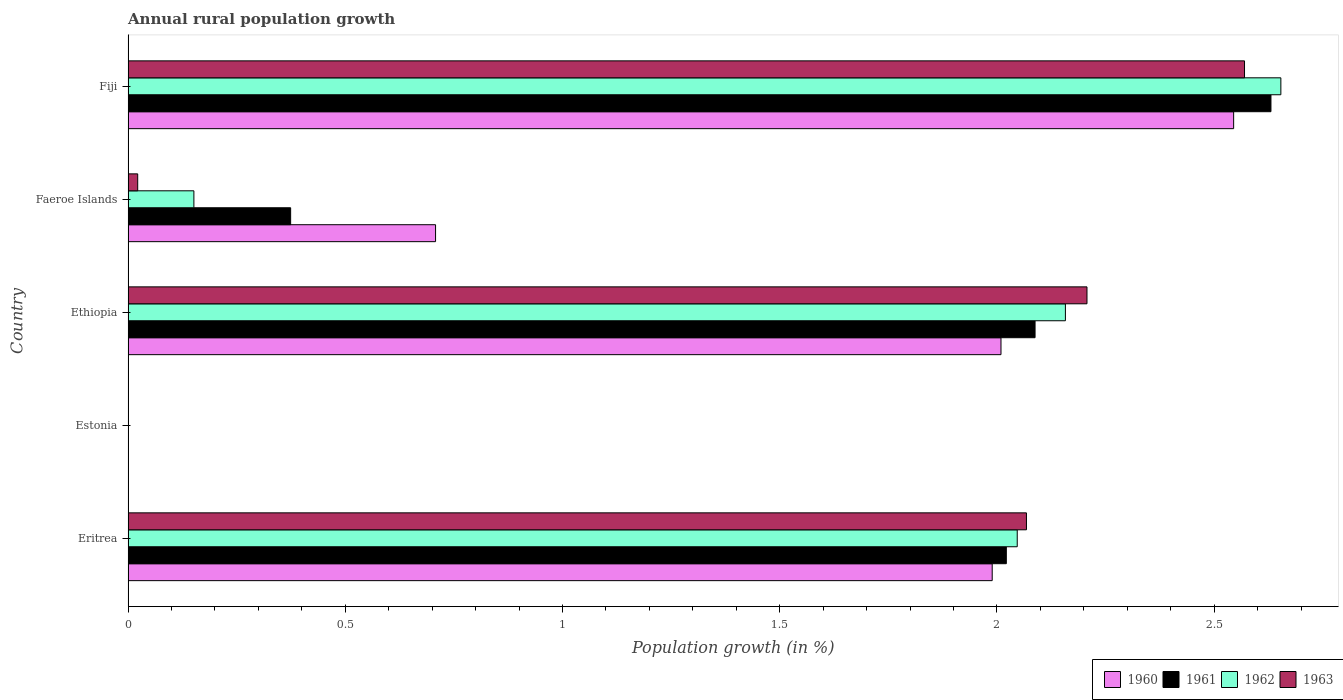How many different coloured bars are there?
Make the answer very short. 4. Are the number of bars per tick equal to the number of legend labels?
Your response must be concise. No. Are the number of bars on each tick of the Y-axis equal?
Offer a very short reply. No. How many bars are there on the 4th tick from the top?
Offer a terse response. 0. How many bars are there on the 2nd tick from the bottom?
Keep it short and to the point. 0. What is the label of the 4th group of bars from the top?
Offer a very short reply. Estonia. In how many cases, is the number of bars for a given country not equal to the number of legend labels?
Your answer should be very brief. 1. What is the percentage of rural population growth in 1960 in Faeroe Islands?
Ensure brevity in your answer.  0.71. Across all countries, what is the maximum percentage of rural population growth in 1963?
Provide a short and direct response. 2.57. In which country was the percentage of rural population growth in 1962 maximum?
Make the answer very short. Fiji. What is the total percentage of rural population growth in 1963 in the graph?
Offer a very short reply. 6.87. What is the difference between the percentage of rural population growth in 1962 in Eritrea and that in Fiji?
Offer a terse response. -0.61. What is the difference between the percentage of rural population growth in 1960 in Fiji and the percentage of rural population growth in 1962 in Estonia?
Offer a very short reply. 2.54. What is the average percentage of rural population growth in 1960 per country?
Keep it short and to the point. 1.45. What is the difference between the percentage of rural population growth in 1960 and percentage of rural population growth in 1962 in Ethiopia?
Provide a succinct answer. -0.15. In how many countries, is the percentage of rural population growth in 1960 greater than 0.9 %?
Give a very brief answer. 3. What is the ratio of the percentage of rural population growth in 1960 in Ethiopia to that in Fiji?
Offer a terse response. 0.79. What is the difference between the highest and the second highest percentage of rural population growth in 1961?
Provide a succinct answer. 0.54. What is the difference between the highest and the lowest percentage of rural population growth in 1962?
Your answer should be compact. 2.65. In how many countries, is the percentage of rural population growth in 1962 greater than the average percentage of rural population growth in 1962 taken over all countries?
Your answer should be very brief. 3. Is the sum of the percentage of rural population growth in 1962 in Faeroe Islands and Fiji greater than the maximum percentage of rural population growth in 1960 across all countries?
Keep it short and to the point. Yes. How many countries are there in the graph?
Give a very brief answer. 5. What is the difference between two consecutive major ticks on the X-axis?
Make the answer very short. 0.5. Where does the legend appear in the graph?
Provide a short and direct response. Bottom right. How many legend labels are there?
Ensure brevity in your answer.  4. How are the legend labels stacked?
Your answer should be compact. Horizontal. What is the title of the graph?
Make the answer very short. Annual rural population growth. What is the label or title of the X-axis?
Offer a terse response. Population growth (in %). What is the label or title of the Y-axis?
Keep it short and to the point. Country. What is the Population growth (in %) in 1960 in Eritrea?
Offer a terse response. 1.99. What is the Population growth (in %) of 1961 in Eritrea?
Ensure brevity in your answer.  2.02. What is the Population growth (in %) in 1962 in Eritrea?
Offer a terse response. 2.05. What is the Population growth (in %) in 1963 in Eritrea?
Provide a succinct answer. 2.07. What is the Population growth (in %) in 1960 in Estonia?
Offer a very short reply. 0. What is the Population growth (in %) in 1961 in Estonia?
Give a very brief answer. 0. What is the Population growth (in %) in 1960 in Ethiopia?
Ensure brevity in your answer.  2.01. What is the Population growth (in %) in 1961 in Ethiopia?
Your answer should be very brief. 2.09. What is the Population growth (in %) of 1962 in Ethiopia?
Make the answer very short. 2.16. What is the Population growth (in %) of 1963 in Ethiopia?
Provide a succinct answer. 2.21. What is the Population growth (in %) of 1960 in Faeroe Islands?
Give a very brief answer. 0.71. What is the Population growth (in %) in 1961 in Faeroe Islands?
Offer a terse response. 0.37. What is the Population growth (in %) in 1962 in Faeroe Islands?
Provide a succinct answer. 0.15. What is the Population growth (in %) of 1963 in Faeroe Islands?
Make the answer very short. 0.02. What is the Population growth (in %) of 1960 in Fiji?
Offer a terse response. 2.54. What is the Population growth (in %) in 1961 in Fiji?
Ensure brevity in your answer.  2.63. What is the Population growth (in %) of 1962 in Fiji?
Keep it short and to the point. 2.65. What is the Population growth (in %) in 1963 in Fiji?
Your response must be concise. 2.57. Across all countries, what is the maximum Population growth (in %) of 1960?
Give a very brief answer. 2.54. Across all countries, what is the maximum Population growth (in %) in 1961?
Ensure brevity in your answer.  2.63. Across all countries, what is the maximum Population growth (in %) in 1962?
Ensure brevity in your answer.  2.65. Across all countries, what is the maximum Population growth (in %) in 1963?
Your response must be concise. 2.57. Across all countries, what is the minimum Population growth (in %) of 1961?
Make the answer very short. 0. What is the total Population growth (in %) in 1960 in the graph?
Ensure brevity in your answer.  7.25. What is the total Population growth (in %) of 1961 in the graph?
Provide a succinct answer. 7.11. What is the total Population growth (in %) of 1962 in the graph?
Provide a succinct answer. 7.01. What is the total Population growth (in %) in 1963 in the graph?
Offer a terse response. 6.87. What is the difference between the Population growth (in %) of 1960 in Eritrea and that in Ethiopia?
Give a very brief answer. -0.02. What is the difference between the Population growth (in %) in 1961 in Eritrea and that in Ethiopia?
Offer a very short reply. -0.07. What is the difference between the Population growth (in %) in 1962 in Eritrea and that in Ethiopia?
Provide a succinct answer. -0.11. What is the difference between the Population growth (in %) of 1963 in Eritrea and that in Ethiopia?
Your answer should be compact. -0.14. What is the difference between the Population growth (in %) of 1960 in Eritrea and that in Faeroe Islands?
Offer a terse response. 1.28. What is the difference between the Population growth (in %) in 1961 in Eritrea and that in Faeroe Islands?
Provide a succinct answer. 1.65. What is the difference between the Population growth (in %) of 1962 in Eritrea and that in Faeroe Islands?
Offer a terse response. 1.9. What is the difference between the Population growth (in %) in 1963 in Eritrea and that in Faeroe Islands?
Your answer should be very brief. 2.05. What is the difference between the Population growth (in %) of 1960 in Eritrea and that in Fiji?
Your answer should be compact. -0.56. What is the difference between the Population growth (in %) of 1961 in Eritrea and that in Fiji?
Give a very brief answer. -0.61. What is the difference between the Population growth (in %) of 1962 in Eritrea and that in Fiji?
Keep it short and to the point. -0.61. What is the difference between the Population growth (in %) of 1963 in Eritrea and that in Fiji?
Your answer should be compact. -0.5. What is the difference between the Population growth (in %) in 1960 in Ethiopia and that in Faeroe Islands?
Your response must be concise. 1.3. What is the difference between the Population growth (in %) in 1961 in Ethiopia and that in Faeroe Islands?
Your answer should be compact. 1.71. What is the difference between the Population growth (in %) in 1962 in Ethiopia and that in Faeroe Islands?
Offer a terse response. 2.01. What is the difference between the Population growth (in %) in 1963 in Ethiopia and that in Faeroe Islands?
Ensure brevity in your answer.  2.19. What is the difference between the Population growth (in %) in 1960 in Ethiopia and that in Fiji?
Your answer should be compact. -0.54. What is the difference between the Population growth (in %) of 1961 in Ethiopia and that in Fiji?
Keep it short and to the point. -0.54. What is the difference between the Population growth (in %) of 1962 in Ethiopia and that in Fiji?
Your response must be concise. -0.5. What is the difference between the Population growth (in %) in 1963 in Ethiopia and that in Fiji?
Provide a succinct answer. -0.36. What is the difference between the Population growth (in %) of 1960 in Faeroe Islands and that in Fiji?
Your answer should be very brief. -1.84. What is the difference between the Population growth (in %) of 1961 in Faeroe Islands and that in Fiji?
Make the answer very short. -2.26. What is the difference between the Population growth (in %) of 1962 in Faeroe Islands and that in Fiji?
Make the answer very short. -2.5. What is the difference between the Population growth (in %) of 1963 in Faeroe Islands and that in Fiji?
Your answer should be compact. -2.55. What is the difference between the Population growth (in %) of 1960 in Eritrea and the Population growth (in %) of 1961 in Ethiopia?
Provide a succinct answer. -0.1. What is the difference between the Population growth (in %) of 1960 in Eritrea and the Population growth (in %) of 1962 in Ethiopia?
Offer a very short reply. -0.17. What is the difference between the Population growth (in %) in 1960 in Eritrea and the Population growth (in %) in 1963 in Ethiopia?
Provide a succinct answer. -0.22. What is the difference between the Population growth (in %) in 1961 in Eritrea and the Population growth (in %) in 1962 in Ethiopia?
Provide a succinct answer. -0.14. What is the difference between the Population growth (in %) of 1961 in Eritrea and the Population growth (in %) of 1963 in Ethiopia?
Offer a very short reply. -0.19. What is the difference between the Population growth (in %) in 1962 in Eritrea and the Population growth (in %) in 1963 in Ethiopia?
Your answer should be very brief. -0.16. What is the difference between the Population growth (in %) in 1960 in Eritrea and the Population growth (in %) in 1961 in Faeroe Islands?
Your answer should be compact. 1.61. What is the difference between the Population growth (in %) of 1960 in Eritrea and the Population growth (in %) of 1962 in Faeroe Islands?
Your answer should be very brief. 1.84. What is the difference between the Population growth (in %) of 1960 in Eritrea and the Population growth (in %) of 1963 in Faeroe Islands?
Make the answer very short. 1.97. What is the difference between the Population growth (in %) in 1961 in Eritrea and the Population growth (in %) in 1962 in Faeroe Islands?
Provide a succinct answer. 1.87. What is the difference between the Population growth (in %) in 1961 in Eritrea and the Population growth (in %) in 1963 in Faeroe Islands?
Keep it short and to the point. 2. What is the difference between the Population growth (in %) of 1962 in Eritrea and the Population growth (in %) of 1963 in Faeroe Islands?
Keep it short and to the point. 2.02. What is the difference between the Population growth (in %) in 1960 in Eritrea and the Population growth (in %) in 1961 in Fiji?
Keep it short and to the point. -0.64. What is the difference between the Population growth (in %) of 1960 in Eritrea and the Population growth (in %) of 1962 in Fiji?
Offer a terse response. -0.66. What is the difference between the Population growth (in %) in 1960 in Eritrea and the Population growth (in %) in 1963 in Fiji?
Offer a terse response. -0.58. What is the difference between the Population growth (in %) in 1961 in Eritrea and the Population growth (in %) in 1962 in Fiji?
Make the answer very short. -0.63. What is the difference between the Population growth (in %) of 1961 in Eritrea and the Population growth (in %) of 1963 in Fiji?
Make the answer very short. -0.55. What is the difference between the Population growth (in %) of 1962 in Eritrea and the Population growth (in %) of 1963 in Fiji?
Provide a short and direct response. -0.52. What is the difference between the Population growth (in %) in 1960 in Ethiopia and the Population growth (in %) in 1961 in Faeroe Islands?
Your answer should be compact. 1.64. What is the difference between the Population growth (in %) of 1960 in Ethiopia and the Population growth (in %) of 1962 in Faeroe Islands?
Offer a terse response. 1.86. What is the difference between the Population growth (in %) of 1960 in Ethiopia and the Population growth (in %) of 1963 in Faeroe Islands?
Offer a terse response. 1.99. What is the difference between the Population growth (in %) in 1961 in Ethiopia and the Population growth (in %) in 1962 in Faeroe Islands?
Your answer should be compact. 1.94. What is the difference between the Population growth (in %) of 1961 in Ethiopia and the Population growth (in %) of 1963 in Faeroe Islands?
Your answer should be compact. 2.07. What is the difference between the Population growth (in %) in 1962 in Ethiopia and the Population growth (in %) in 1963 in Faeroe Islands?
Ensure brevity in your answer.  2.14. What is the difference between the Population growth (in %) of 1960 in Ethiopia and the Population growth (in %) of 1961 in Fiji?
Ensure brevity in your answer.  -0.62. What is the difference between the Population growth (in %) in 1960 in Ethiopia and the Population growth (in %) in 1962 in Fiji?
Ensure brevity in your answer.  -0.64. What is the difference between the Population growth (in %) of 1960 in Ethiopia and the Population growth (in %) of 1963 in Fiji?
Give a very brief answer. -0.56. What is the difference between the Population growth (in %) of 1961 in Ethiopia and the Population growth (in %) of 1962 in Fiji?
Keep it short and to the point. -0.57. What is the difference between the Population growth (in %) in 1961 in Ethiopia and the Population growth (in %) in 1963 in Fiji?
Your answer should be compact. -0.48. What is the difference between the Population growth (in %) of 1962 in Ethiopia and the Population growth (in %) of 1963 in Fiji?
Give a very brief answer. -0.41. What is the difference between the Population growth (in %) of 1960 in Faeroe Islands and the Population growth (in %) of 1961 in Fiji?
Your response must be concise. -1.92. What is the difference between the Population growth (in %) in 1960 in Faeroe Islands and the Population growth (in %) in 1962 in Fiji?
Your answer should be very brief. -1.95. What is the difference between the Population growth (in %) in 1960 in Faeroe Islands and the Population growth (in %) in 1963 in Fiji?
Provide a succinct answer. -1.86. What is the difference between the Population growth (in %) of 1961 in Faeroe Islands and the Population growth (in %) of 1962 in Fiji?
Ensure brevity in your answer.  -2.28. What is the difference between the Population growth (in %) of 1961 in Faeroe Islands and the Population growth (in %) of 1963 in Fiji?
Keep it short and to the point. -2.2. What is the difference between the Population growth (in %) in 1962 in Faeroe Islands and the Population growth (in %) in 1963 in Fiji?
Your response must be concise. -2.42. What is the average Population growth (in %) of 1960 per country?
Offer a terse response. 1.45. What is the average Population growth (in %) in 1961 per country?
Your answer should be compact. 1.42. What is the average Population growth (in %) of 1962 per country?
Keep it short and to the point. 1.4. What is the average Population growth (in %) of 1963 per country?
Offer a very short reply. 1.37. What is the difference between the Population growth (in %) of 1960 and Population growth (in %) of 1961 in Eritrea?
Your answer should be compact. -0.03. What is the difference between the Population growth (in %) in 1960 and Population growth (in %) in 1962 in Eritrea?
Give a very brief answer. -0.06. What is the difference between the Population growth (in %) in 1960 and Population growth (in %) in 1963 in Eritrea?
Ensure brevity in your answer.  -0.08. What is the difference between the Population growth (in %) in 1961 and Population growth (in %) in 1962 in Eritrea?
Provide a short and direct response. -0.03. What is the difference between the Population growth (in %) of 1961 and Population growth (in %) of 1963 in Eritrea?
Make the answer very short. -0.05. What is the difference between the Population growth (in %) in 1962 and Population growth (in %) in 1963 in Eritrea?
Make the answer very short. -0.02. What is the difference between the Population growth (in %) in 1960 and Population growth (in %) in 1961 in Ethiopia?
Provide a short and direct response. -0.08. What is the difference between the Population growth (in %) in 1960 and Population growth (in %) in 1962 in Ethiopia?
Your answer should be very brief. -0.15. What is the difference between the Population growth (in %) in 1960 and Population growth (in %) in 1963 in Ethiopia?
Your answer should be very brief. -0.2. What is the difference between the Population growth (in %) in 1961 and Population growth (in %) in 1962 in Ethiopia?
Provide a succinct answer. -0.07. What is the difference between the Population growth (in %) of 1961 and Population growth (in %) of 1963 in Ethiopia?
Offer a terse response. -0.12. What is the difference between the Population growth (in %) in 1962 and Population growth (in %) in 1963 in Ethiopia?
Ensure brevity in your answer.  -0.05. What is the difference between the Population growth (in %) in 1960 and Population growth (in %) in 1961 in Faeroe Islands?
Ensure brevity in your answer.  0.33. What is the difference between the Population growth (in %) of 1960 and Population growth (in %) of 1962 in Faeroe Islands?
Your answer should be compact. 0.56. What is the difference between the Population growth (in %) in 1960 and Population growth (in %) in 1963 in Faeroe Islands?
Provide a succinct answer. 0.69. What is the difference between the Population growth (in %) of 1961 and Population growth (in %) of 1962 in Faeroe Islands?
Offer a very short reply. 0.22. What is the difference between the Population growth (in %) in 1961 and Population growth (in %) in 1963 in Faeroe Islands?
Keep it short and to the point. 0.35. What is the difference between the Population growth (in %) in 1962 and Population growth (in %) in 1963 in Faeroe Islands?
Your answer should be very brief. 0.13. What is the difference between the Population growth (in %) in 1960 and Population growth (in %) in 1961 in Fiji?
Give a very brief answer. -0.09. What is the difference between the Population growth (in %) in 1960 and Population growth (in %) in 1962 in Fiji?
Offer a terse response. -0.11. What is the difference between the Population growth (in %) in 1960 and Population growth (in %) in 1963 in Fiji?
Your answer should be compact. -0.03. What is the difference between the Population growth (in %) in 1961 and Population growth (in %) in 1962 in Fiji?
Ensure brevity in your answer.  -0.02. What is the difference between the Population growth (in %) in 1961 and Population growth (in %) in 1963 in Fiji?
Provide a short and direct response. 0.06. What is the difference between the Population growth (in %) in 1962 and Population growth (in %) in 1963 in Fiji?
Provide a short and direct response. 0.08. What is the ratio of the Population growth (in %) in 1960 in Eritrea to that in Ethiopia?
Your response must be concise. 0.99. What is the ratio of the Population growth (in %) in 1961 in Eritrea to that in Ethiopia?
Provide a short and direct response. 0.97. What is the ratio of the Population growth (in %) of 1962 in Eritrea to that in Ethiopia?
Offer a terse response. 0.95. What is the ratio of the Population growth (in %) of 1963 in Eritrea to that in Ethiopia?
Your response must be concise. 0.94. What is the ratio of the Population growth (in %) in 1960 in Eritrea to that in Faeroe Islands?
Your response must be concise. 2.81. What is the ratio of the Population growth (in %) of 1961 in Eritrea to that in Faeroe Islands?
Keep it short and to the point. 5.4. What is the ratio of the Population growth (in %) of 1962 in Eritrea to that in Faeroe Islands?
Your answer should be compact. 13.51. What is the ratio of the Population growth (in %) of 1963 in Eritrea to that in Faeroe Islands?
Make the answer very short. 93.35. What is the ratio of the Population growth (in %) in 1960 in Eritrea to that in Fiji?
Provide a short and direct response. 0.78. What is the ratio of the Population growth (in %) of 1961 in Eritrea to that in Fiji?
Keep it short and to the point. 0.77. What is the ratio of the Population growth (in %) in 1962 in Eritrea to that in Fiji?
Give a very brief answer. 0.77. What is the ratio of the Population growth (in %) in 1963 in Eritrea to that in Fiji?
Keep it short and to the point. 0.8. What is the ratio of the Population growth (in %) in 1960 in Ethiopia to that in Faeroe Islands?
Your answer should be very brief. 2.84. What is the ratio of the Population growth (in %) in 1961 in Ethiopia to that in Faeroe Islands?
Your answer should be compact. 5.58. What is the ratio of the Population growth (in %) in 1962 in Ethiopia to that in Faeroe Islands?
Make the answer very short. 14.24. What is the ratio of the Population growth (in %) of 1963 in Ethiopia to that in Faeroe Islands?
Give a very brief answer. 99.64. What is the ratio of the Population growth (in %) in 1960 in Ethiopia to that in Fiji?
Provide a short and direct response. 0.79. What is the ratio of the Population growth (in %) in 1961 in Ethiopia to that in Fiji?
Your answer should be compact. 0.79. What is the ratio of the Population growth (in %) of 1962 in Ethiopia to that in Fiji?
Offer a terse response. 0.81. What is the ratio of the Population growth (in %) of 1963 in Ethiopia to that in Fiji?
Provide a succinct answer. 0.86. What is the ratio of the Population growth (in %) of 1960 in Faeroe Islands to that in Fiji?
Your answer should be very brief. 0.28. What is the ratio of the Population growth (in %) of 1961 in Faeroe Islands to that in Fiji?
Your answer should be compact. 0.14. What is the ratio of the Population growth (in %) in 1962 in Faeroe Islands to that in Fiji?
Ensure brevity in your answer.  0.06. What is the ratio of the Population growth (in %) in 1963 in Faeroe Islands to that in Fiji?
Provide a short and direct response. 0.01. What is the difference between the highest and the second highest Population growth (in %) in 1960?
Offer a terse response. 0.54. What is the difference between the highest and the second highest Population growth (in %) of 1961?
Your answer should be very brief. 0.54. What is the difference between the highest and the second highest Population growth (in %) of 1962?
Offer a terse response. 0.5. What is the difference between the highest and the second highest Population growth (in %) of 1963?
Offer a terse response. 0.36. What is the difference between the highest and the lowest Population growth (in %) in 1960?
Your answer should be compact. 2.54. What is the difference between the highest and the lowest Population growth (in %) of 1961?
Provide a succinct answer. 2.63. What is the difference between the highest and the lowest Population growth (in %) in 1962?
Keep it short and to the point. 2.65. What is the difference between the highest and the lowest Population growth (in %) of 1963?
Provide a short and direct response. 2.57. 